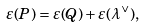Convert formula to latex. <formula><loc_0><loc_0><loc_500><loc_500>\varepsilon ( P ) = \varepsilon ( Q ) + \varepsilon ( \lambda ^ { \vee } ) ,</formula> 